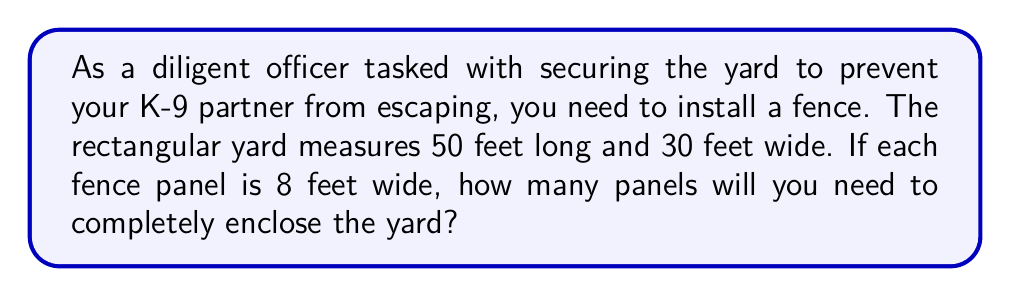Can you answer this question? Let's approach this step-by-step:

1) First, calculate the perimeter of the rectangular yard:
   $$\text{Perimeter} = 2 \times (\text{length} + \text{width})$$
   $$\text{Perimeter} = 2 \times (50 \text{ ft} + 30 \text{ ft}) = 2 \times 80 \text{ ft} = 160 \text{ ft}$$

2) Now, we know that the total length of fencing needed is 160 feet.

3) Each fence panel is 8 feet wide. To find the number of panels, we divide the total perimeter by the width of each panel:
   $$\text{Number of panels} = \frac{\text{Perimeter}}{\text{Panel width}}$$
   $$\text{Number of panels} = \frac{160 \text{ ft}}{8 \text{ ft/panel}} = 20 \text{ panels}$$

4) Since we can't use partial panels, we need to round up to the nearest whole number. In this case, 20 is already a whole number, so no rounding is necessary.

Therefore, you will need 20 fence panels to completely enclose the yard.
Answer: 20 panels 